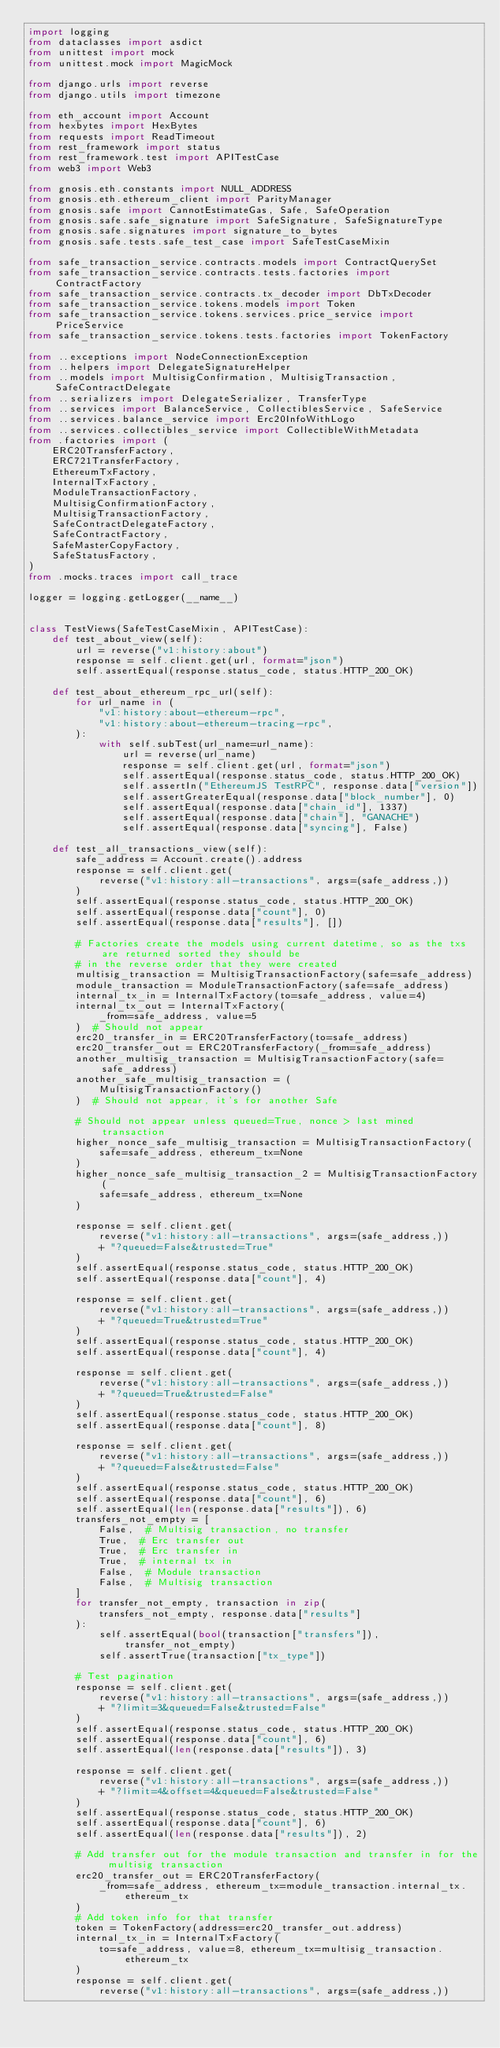<code> <loc_0><loc_0><loc_500><loc_500><_Python_>import logging
from dataclasses import asdict
from unittest import mock
from unittest.mock import MagicMock

from django.urls import reverse
from django.utils import timezone

from eth_account import Account
from hexbytes import HexBytes
from requests import ReadTimeout
from rest_framework import status
from rest_framework.test import APITestCase
from web3 import Web3

from gnosis.eth.constants import NULL_ADDRESS
from gnosis.eth.ethereum_client import ParityManager
from gnosis.safe import CannotEstimateGas, Safe, SafeOperation
from gnosis.safe.safe_signature import SafeSignature, SafeSignatureType
from gnosis.safe.signatures import signature_to_bytes
from gnosis.safe.tests.safe_test_case import SafeTestCaseMixin

from safe_transaction_service.contracts.models import ContractQuerySet
from safe_transaction_service.contracts.tests.factories import ContractFactory
from safe_transaction_service.contracts.tx_decoder import DbTxDecoder
from safe_transaction_service.tokens.models import Token
from safe_transaction_service.tokens.services.price_service import PriceService
from safe_transaction_service.tokens.tests.factories import TokenFactory

from ..exceptions import NodeConnectionException
from ..helpers import DelegateSignatureHelper
from ..models import MultisigConfirmation, MultisigTransaction, SafeContractDelegate
from ..serializers import DelegateSerializer, TransferType
from ..services import BalanceService, CollectiblesService, SafeService
from ..services.balance_service import Erc20InfoWithLogo
from ..services.collectibles_service import CollectibleWithMetadata
from .factories import (
    ERC20TransferFactory,
    ERC721TransferFactory,
    EthereumTxFactory,
    InternalTxFactory,
    ModuleTransactionFactory,
    MultisigConfirmationFactory,
    MultisigTransactionFactory,
    SafeContractDelegateFactory,
    SafeContractFactory,
    SafeMasterCopyFactory,
    SafeStatusFactory,
)
from .mocks.traces import call_trace

logger = logging.getLogger(__name__)


class TestViews(SafeTestCaseMixin, APITestCase):
    def test_about_view(self):
        url = reverse("v1:history:about")
        response = self.client.get(url, format="json")
        self.assertEqual(response.status_code, status.HTTP_200_OK)

    def test_about_ethereum_rpc_url(self):
        for url_name in (
            "v1:history:about-ethereum-rpc",
            "v1:history:about-ethereum-tracing-rpc",
        ):
            with self.subTest(url_name=url_name):
                url = reverse(url_name)
                response = self.client.get(url, format="json")
                self.assertEqual(response.status_code, status.HTTP_200_OK)
                self.assertIn("EthereumJS TestRPC", response.data["version"])
                self.assertGreaterEqual(response.data["block_number"], 0)
                self.assertEqual(response.data["chain_id"], 1337)
                self.assertEqual(response.data["chain"], "GANACHE")
                self.assertEqual(response.data["syncing"], False)

    def test_all_transactions_view(self):
        safe_address = Account.create().address
        response = self.client.get(
            reverse("v1:history:all-transactions", args=(safe_address,))
        )
        self.assertEqual(response.status_code, status.HTTP_200_OK)
        self.assertEqual(response.data["count"], 0)
        self.assertEqual(response.data["results"], [])

        # Factories create the models using current datetime, so as the txs are returned sorted they should be
        # in the reverse order that they were created
        multisig_transaction = MultisigTransactionFactory(safe=safe_address)
        module_transaction = ModuleTransactionFactory(safe=safe_address)
        internal_tx_in = InternalTxFactory(to=safe_address, value=4)
        internal_tx_out = InternalTxFactory(
            _from=safe_address, value=5
        )  # Should not appear
        erc20_transfer_in = ERC20TransferFactory(to=safe_address)
        erc20_transfer_out = ERC20TransferFactory(_from=safe_address)
        another_multisig_transaction = MultisigTransactionFactory(safe=safe_address)
        another_safe_multisig_transaction = (
            MultisigTransactionFactory()
        )  # Should not appear, it's for another Safe

        # Should not appear unless queued=True, nonce > last mined transaction
        higher_nonce_safe_multisig_transaction = MultisigTransactionFactory(
            safe=safe_address, ethereum_tx=None
        )
        higher_nonce_safe_multisig_transaction_2 = MultisigTransactionFactory(
            safe=safe_address, ethereum_tx=None
        )

        response = self.client.get(
            reverse("v1:history:all-transactions", args=(safe_address,))
            + "?queued=False&trusted=True"
        )
        self.assertEqual(response.status_code, status.HTTP_200_OK)
        self.assertEqual(response.data["count"], 4)

        response = self.client.get(
            reverse("v1:history:all-transactions", args=(safe_address,))
            + "?queued=True&trusted=True"
        )
        self.assertEqual(response.status_code, status.HTTP_200_OK)
        self.assertEqual(response.data["count"], 4)

        response = self.client.get(
            reverse("v1:history:all-transactions", args=(safe_address,))
            + "?queued=True&trusted=False"
        )
        self.assertEqual(response.status_code, status.HTTP_200_OK)
        self.assertEqual(response.data["count"], 8)

        response = self.client.get(
            reverse("v1:history:all-transactions", args=(safe_address,))
            + "?queued=False&trusted=False"
        )
        self.assertEqual(response.status_code, status.HTTP_200_OK)
        self.assertEqual(response.data["count"], 6)
        self.assertEqual(len(response.data["results"]), 6)
        transfers_not_empty = [
            False,  # Multisig transaction, no transfer
            True,  # Erc transfer out
            True,  # Erc transfer in
            True,  # internal tx in
            False,  # Module transaction
            False,  # Multisig transaction
        ]
        for transfer_not_empty, transaction in zip(
            transfers_not_empty, response.data["results"]
        ):
            self.assertEqual(bool(transaction["transfers"]), transfer_not_empty)
            self.assertTrue(transaction["tx_type"])

        # Test pagination
        response = self.client.get(
            reverse("v1:history:all-transactions", args=(safe_address,))
            + "?limit=3&queued=False&trusted=False"
        )
        self.assertEqual(response.status_code, status.HTTP_200_OK)
        self.assertEqual(response.data["count"], 6)
        self.assertEqual(len(response.data["results"]), 3)

        response = self.client.get(
            reverse("v1:history:all-transactions", args=(safe_address,))
            + "?limit=4&offset=4&queued=False&trusted=False"
        )
        self.assertEqual(response.status_code, status.HTTP_200_OK)
        self.assertEqual(response.data["count"], 6)
        self.assertEqual(len(response.data["results"]), 2)

        # Add transfer out for the module transaction and transfer in for the multisig transaction
        erc20_transfer_out = ERC20TransferFactory(
            _from=safe_address, ethereum_tx=module_transaction.internal_tx.ethereum_tx
        )
        # Add token info for that transfer
        token = TokenFactory(address=erc20_transfer_out.address)
        internal_tx_in = InternalTxFactory(
            to=safe_address, value=8, ethereum_tx=multisig_transaction.ethereum_tx
        )
        response = self.client.get(
            reverse("v1:history:all-transactions", args=(safe_address,))</code> 